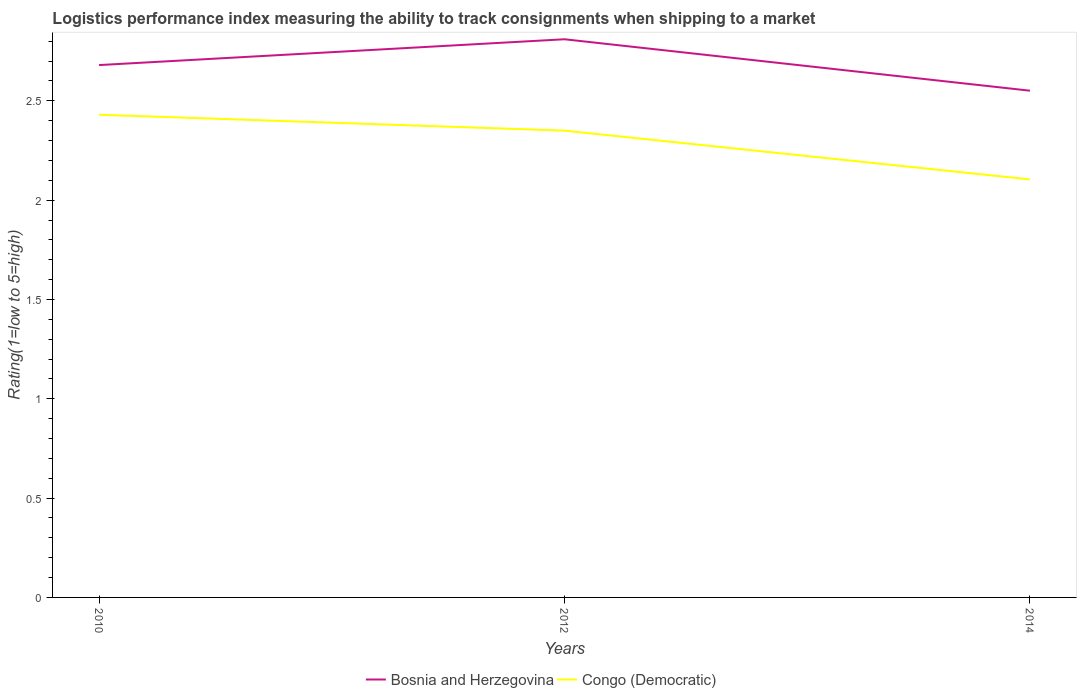Does the line corresponding to Bosnia and Herzegovina intersect with the line corresponding to Congo (Democratic)?
Keep it short and to the point. No. Across all years, what is the maximum Logistic performance index in Bosnia and Herzegovina?
Ensure brevity in your answer.  2.55. What is the total Logistic performance index in Congo (Democratic) in the graph?
Your answer should be very brief. 0.08. What is the difference between the highest and the second highest Logistic performance index in Bosnia and Herzegovina?
Provide a short and direct response. 0.26. What is the difference between the highest and the lowest Logistic performance index in Congo (Democratic)?
Ensure brevity in your answer.  2. Is the Logistic performance index in Congo (Democratic) strictly greater than the Logistic performance index in Bosnia and Herzegovina over the years?
Your answer should be compact. Yes. How many lines are there?
Your response must be concise. 2. Are the values on the major ticks of Y-axis written in scientific E-notation?
Offer a very short reply. No. Does the graph contain any zero values?
Keep it short and to the point. No. Does the graph contain grids?
Your answer should be very brief. No. How many legend labels are there?
Offer a very short reply. 2. What is the title of the graph?
Keep it short and to the point. Logistics performance index measuring the ability to track consignments when shipping to a market. What is the label or title of the Y-axis?
Offer a very short reply. Rating(1=low to 5=high). What is the Rating(1=low to 5=high) in Bosnia and Herzegovina in 2010?
Keep it short and to the point. 2.68. What is the Rating(1=low to 5=high) in Congo (Democratic) in 2010?
Ensure brevity in your answer.  2.43. What is the Rating(1=low to 5=high) in Bosnia and Herzegovina in 2012?
Your answer should be very brief. 2.81. What is the Rating(1=low to 5=high) in Congo (Democratic) in 2012?
Make the answer very short. 2.35. What is the Rating(1=low to 5=high) of Bosnia and Herzegovina in 2014?
Provide a short and direct response. 2.55. What is the Rating(1=low to 5=high) of Congo (Democratic) in 2014?
Offer a very short reply. 2.1. Across all years, what is the maximum Rating(1=low to 5=high) of Bosnia and Herzegovina?
Offer a very short reply. 2.81. Across all years, what is the maximum Rating(1=low to 5=high) in Congo (Democratic)?
Your answer should be compact. 2.43. Across all years, what is the minimum Rating(1=low to 5=high) in Bosnia and Herzegovina?
Keep it short and to the point. 2.55. Across all years, what is the minimum Rating(1=low to 5=high) in Congo (Democratic)?
Offer a very short reply. 2.1. What is the total Rating(1=low to 5=high) of Bosnia and Herzegovina in the graph?
Provide a short and direct response. 8.04. What is the total Rating(1=low to 5=high) in Congo (Democratic) in the graph?
Your response must be concise. 6.88. What is the difference between the Rating(1=low to 5=high) in Bosnia and Herzegovina in 2010 and that in 2012?
Offer a terse response. -0.13. What is the difference between the Rating(1=low to 5=high) in Bosnia and Herzegovina in 2010 and that in 2014?
Offer a very short reply. 0.13. What is the difference between the Rating(1=low to 5=high) in Congo (Democratic) in 2010 and that in 2014?
Offer a terse response. 0.33. What is the difference between the Rating(1=low to 5=high) of Bosnia and Herzegovina in 2012 and that in 2014?
Keep it short and to the point. 0.26. What is the difference between the Rating(1=low to 5=high) in Congo (Democratic) in 2012 and that in 2014?
Offer a very short reply. 0.25. What is the difference between the Rating(1=low to 5=high) in Bosnia and Herzegovina in 2010 and the Rating(1=low to 5=high) in Congo (Democratic) in 2012?
Offer a terse response. 0.33. What is the difference between the Rating(1=low to 5=high) in Bosnia and Herzegovina in 2010 and the Rating(1=low to 5=high) in Congo (Democratic) in 2014?
Make the answer very short. 0.58. What is the difference between the Rating(1=low to 5=high) of Bosnia and Herzegovina in 2012 and the Rating(1=low to 5=high) of Congo (Democratic) in 2014?
Give a very brief answer. 0.71. What is the average Rating(1=low to 5=high) of Bosnia and Herzegovina per year?
Make the answer very short. 2.68. What is the average Rating(1=low to 5=high) in Congo (Democratic) per year?
Make the answer very short. 2.29. In the year 2010, what is the difference between the Rating(1=low to 5=high) in Bosnia and Herzegovina and Rating(1=low to 5=high) in Congo (Democratic)?
Make the answer very short. 0.25. In the year 2012, what is the difference between the Rating(1=low to 5=high) in Bosnia and Herzegovina and Rating(1=low to 5=high) in Congo (Democratic)?
Make the answer very short. 0.46. In the year 2014, what is the difference between the Rating(1=low to 5=high) of Bosnia and Herzegovina and Rating(1=low to 5=high) of Congo (Democratic)?
Provide a short and direct response. 0.45. What is the ratio of the Rating(1=low to 5=high) in Bosnia and Herzegovina in 2010 to that in 2012?
Your answer should be very brief. 0.95. What is the ratio of the Rating(1=low to 5=high) in Congo (Democratic) in 2010 to that in 2012?
Give a very brief answer. 1.03. What is the ratio of the Rating(1=low to 5=high) of Bosnia and Herzegovina in 2010 to that in 2014?
Ensure brevity in your answer.  1.05. What is the ratio of the Rating(1=low to 5=high) of Congo (Democratic) in 2010 to that in 2014?
Offer a terse response. 1.15. What is the ratio of the Rating(1=low to 5=high) in Bosnia and Herzegovina in 2012 to that in 2014?
Offer a very short reply. 1.1. What is the ratio of the Rating(1=low to 5=high) of Congo (Democratic) in 2012 to that in 2014?
Your response must be concise. 1.12. What is the difference between the highest and the second highest Rating(1=low to 5=high) of Bosnia and Herzegovina?
Give a very brief answer. 0.13. What is the difference between the highest and the second highest Rating(1=low to 5=high) of Congo (Democratic)?
Your response must be concise. 0.08. What is the difference between the highest and the lowest Rating(1=low to 5=high) of Bosnia and Herzegovina?
Make the answer very short. 0.26. What is the difference between the highest and the lowest Rating(1=low to 5=high) in Congo (Democratic)?
Your response must be concise. 0.33. 